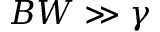<formula> <loc_0><loc_0><loc_500><loc_500>B W \gg \gamma</formula> 